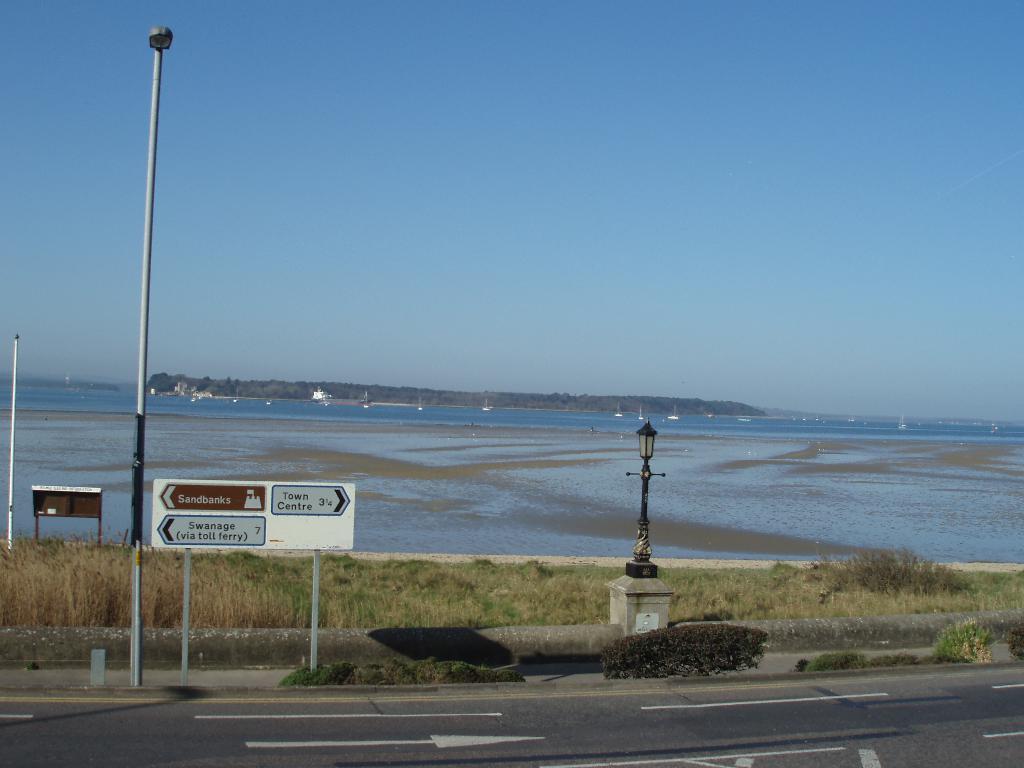Describe this image in one or two sentences. In this image we can see grass, sign board, street light, a light pole on the pillar beside the road and in the background there is water, mountains and the sky. 